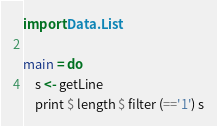Convert code to text. <code><loc_0><loc_0><loc_500><loc_500><_Haskell_>import Data.List

main = do
    s <- getLine
    print $ length $ filter (=='1') s</code> 